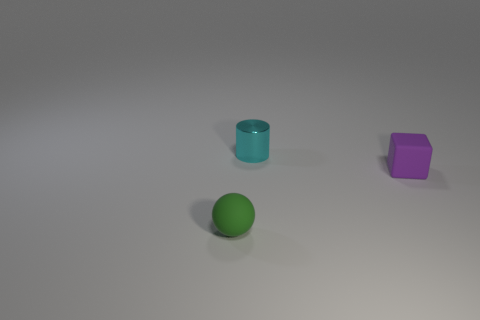How many small things are in front of the purple cube and behind the purple object?
Provide a short and direct response. 0. What is the material of the ball that is the same size as the cylinder?
Your response must be concise. Rubber. There is a thing that is to the right of the shiny object; does it have the same size as the object that is to the left of the metal thing?
Keep it short and to the point. Yes. Are there any cylinders left of the shiny cylinder?
Offer a very short reply. No. The small rubber object in front of the tiny thing that is on the right side of the tiny cyan metal cylinder is what color?
Your answer should be compact. Green. Is the number of tiny gray rubber objects less than the number of green things?
Provide a succinct answer. Yes. The block that is the same size as the cyan shiny cylinder is what color?
Provide a short and direct response. Purple. Is the number of purple cubes that are in front of the sphere the same as the number of cyan cylinders in front of the tiny purple matte block?
Offer a very short reply. Yes. Are there any green metallic blocks that have the same size as the green matte object?
Offer a very short reply. No. How big is the purple matte thing?
Make the answer very short. Small. 